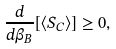<formula> <loc_0><loc_0><loc_500><loc_500>\frac { d } { d \beta _ { B } } [ \langle S _ { C } \rangle ] \geq 0 ,</formula> 